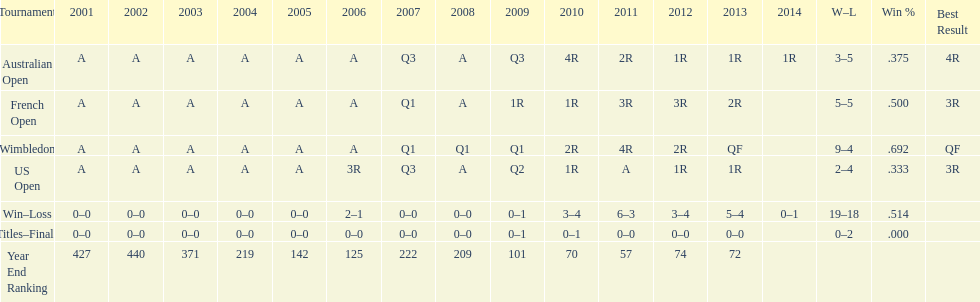Which year end ranking was higher, 2004 or 2011? 2011. 